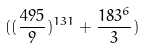<formula> <loc_0><loc_0><loc_500><loc_500>( ( \frac { 4 9 5 } { 9 } ) ^ { 1 3 1 } + \frac { 1 8 3 ^ { 6 } } { 3 } )</formula> 